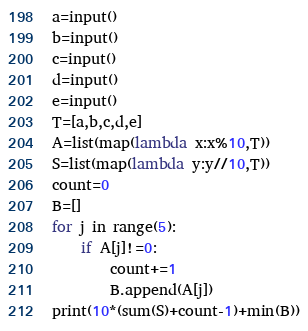<code> <loc_0><loc_0><loc_500><loc_500><_Python_>a=input()
b=input()
c=input()
d=input()
e=input()
T=[a,b,c,d,e]
A=list(map(lambda x:x%10,T))
S=list(map(lambda y:y//10,T))
count=0
B=[]
for j in range(5):
    if A[j]!=0:
        count+=1
        B.append(A[j])
print(10*(sum(S)+count-1)+min(B))</code> 